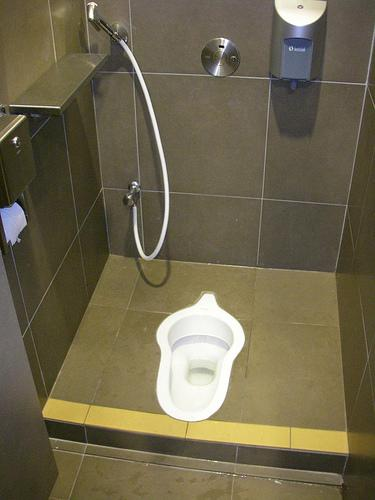Question: why is there a hole in the floor?
Choices:
A. For a water pipe.
B. To serve as a urinal.
C. For the heating system.
D. For a nail.
Answer with the letter. Answer: B Question: where was this photo taken?
Choices:
A. A living room.
B. A kitchen.
C. A bathroom.
D. A dining room.
Answer with the letter. Answer: C Question: what color is the strip on the floor?
Choices:
A. Blue.
B. Red.
C. White.
D. Yellow.
Answer with the letter. Answer: D Question: what type of material was used in this bathroom?
Choices:
A. Tile.
B. Chrome.
C. Porcelain.
D. Drywall.
Answer with the letter. Answer: A Question: who is in this picture?
Choices:
A. Everybody.
B. All.
C. No one.
D. The group.
Answer with the letter. Answer: C Question: how many people are in this photo?
Choices:
A. One.
B. Zero.
C. Two.
D. Three.
Answer with the letter. Answer: B 